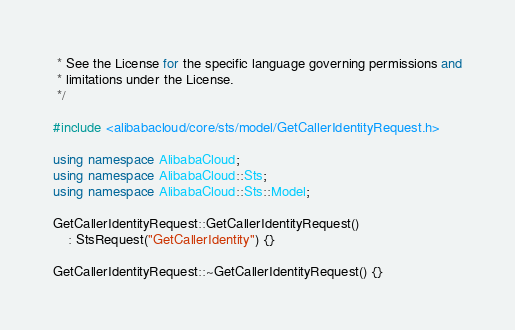<code> <loc_0><loc_0><loc_500><loc_500><_C++_> * See the License for the specific language governing permissions and
 * limitations under the License.
 */

#include <alibabacloud/core/sts/model/GetCallerIdentityRequest.h>

using namespace AlibabaCloud;
using namespace AlibabaCloud::Sts;
using namespace AlibabaCloud::Sts::Model;

GetCallerIdentityRequest::GetCallerIdentityRequest()
    : StsRequest("GetCallerIdentity") {}

GetCallerIdentityRequest::~GetCallerIdentityRequest() {}
</code> 